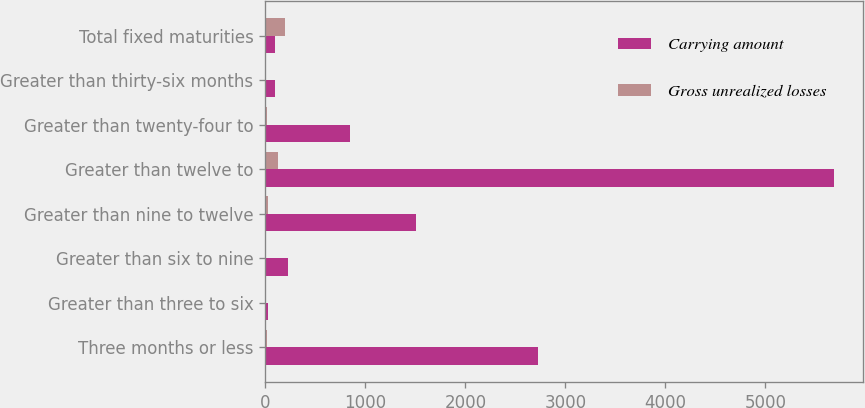Convert chart to OTSL. <chart><loc_0><loc_0><loc_500><loc_500><stacked_bar_chart><ecel><fcel>Three months or less<fcel>Greater than three to six<fcel>Greater than six to nine<fcel>Greater than nine to twelve<fcel>Greater than twelve to<fcel>Greater than twenty-four to<fcel>Greater than thirty-six months<fcel>Total fixed maturities<nl><fcel>Carrying amount<fcel>2730.4<fcel>30.3<fcel>224.8<fcel>1502.6<fcel>5688.9<fcel>843.4<fcel>101.5<fcel>101.5<nl><fcel>Gross unrealized losses<fcel>17.6<fcel>0.4<fcel>1.6<fcel>28.2<fcel>126<fcel>22.9<fcel>4.8<fcel>201.5<nl></chart> 